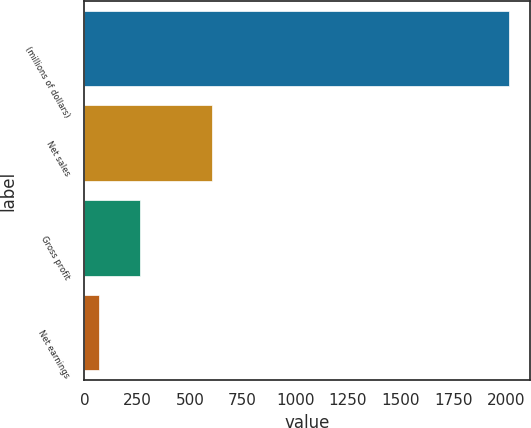<chart> <loc_0><loc_0><loc_500><loc_500><bar_chart><fcel>(millions of dollars)<fcel>Net sales<fcel>Gross profit<fcel>Net earnings<nl><fcel>2013<fcel>604<fcel>262.77<fcel>68.3<nl></chart> 